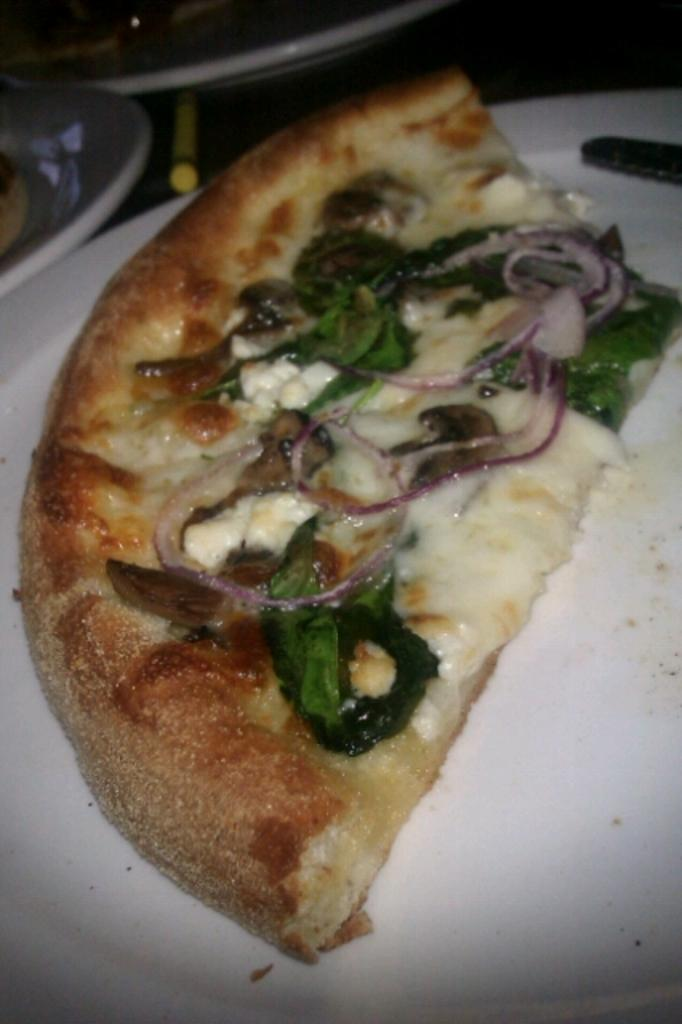What is on the plate in the image? There are food items served on a plate in the image. Can you describe the object on the plate? There is an object on the plate, but its specific nature cannot be determined from the provided facts. What can be seen in the top left corner of the image? There are objects present in the top left corner of the image, but their specific nature cannot be determined from the provided facts. How many steps are visible in the image? There are no steps visible in the image. What type of celery is being used as a garnish on the plate? There is no celery present in the image, and therefore no such garnish can be observed. 